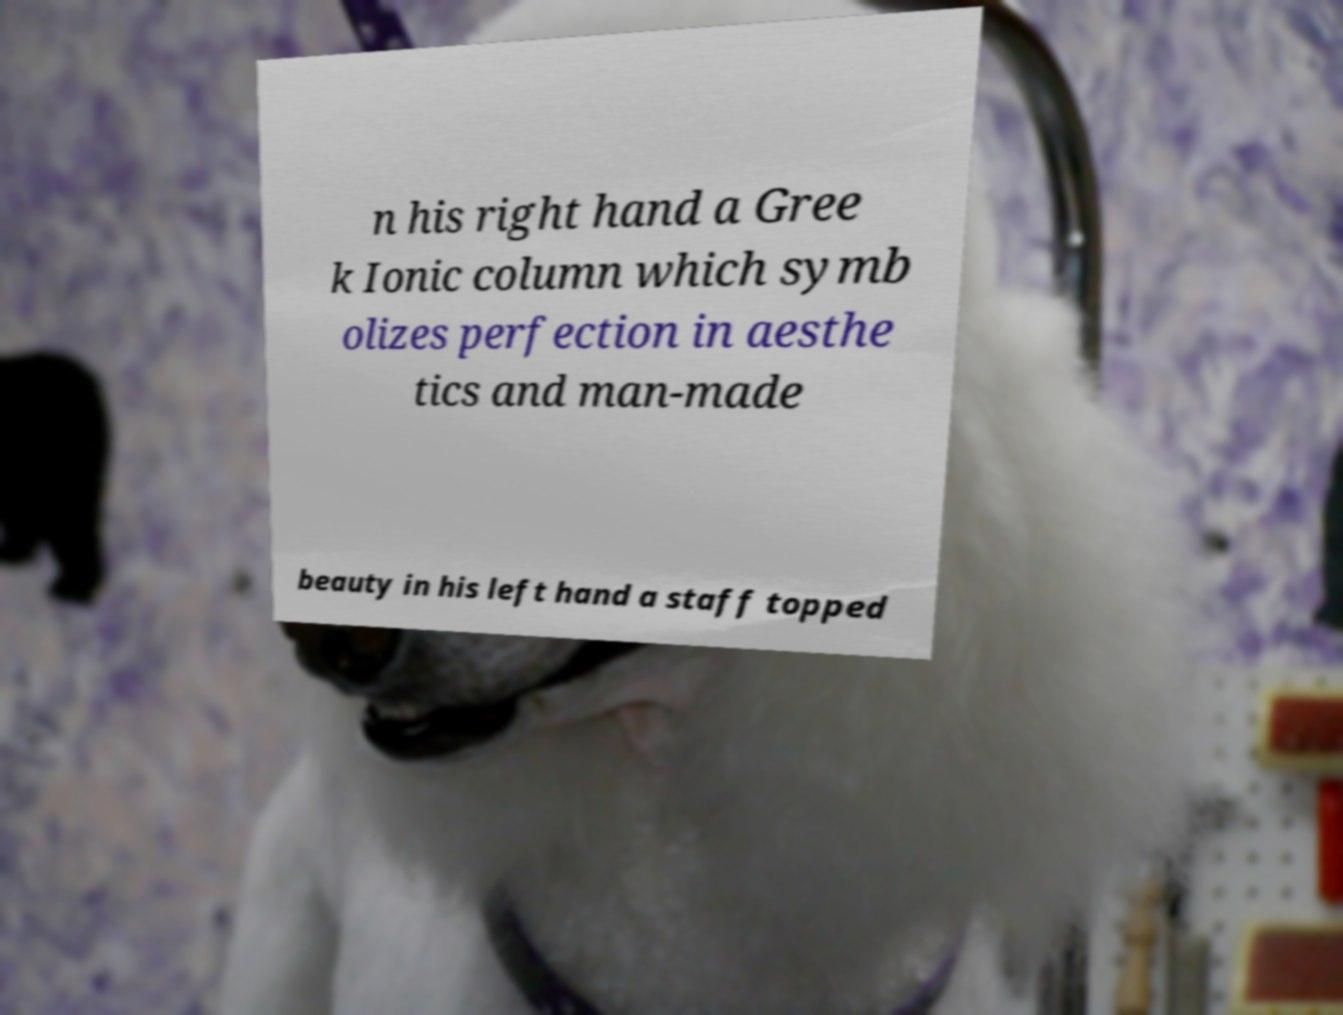Can you read and provide the text displayed in the image?This photo seems to have some interesting text. Can you extract and type it out for me? n his right hand a Gree k Ionic column which symb olizes perfection in aesthe tics and man-made beauty in his left hand a staff topped 